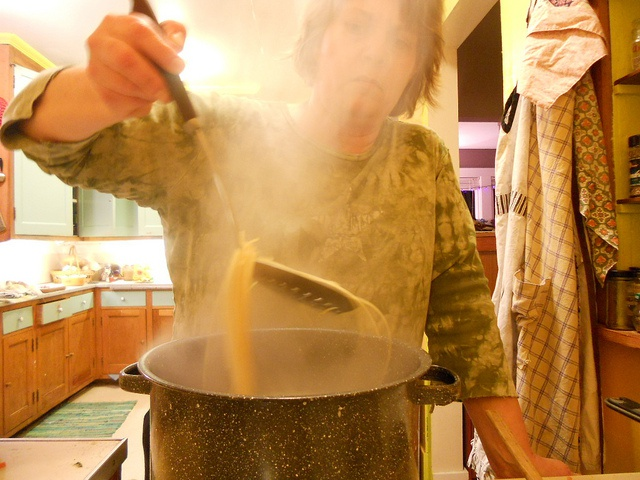Describe the objects in this image and their specific colors. I can see people in white, tan, olive, and orange tones, spoon in white, olive, maroon, tan, and orange tones, and bottle in white, maroon, black, and olive tones in this image. 